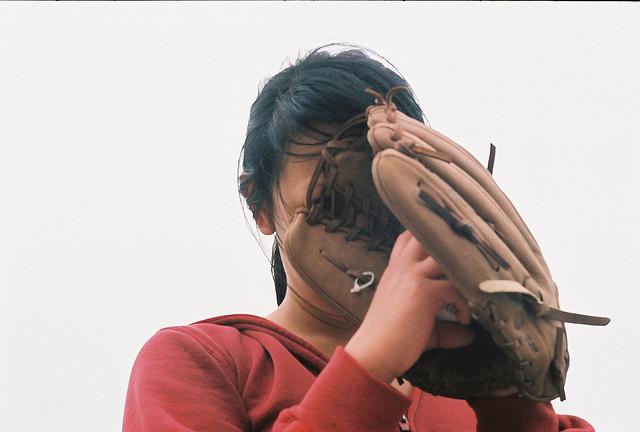What is the glove blocking?
Concise answer only. Face. What type of glove is this?
Answer briefly. Baseball. What is the woman doing?
Short answer required. Playing baseball. 